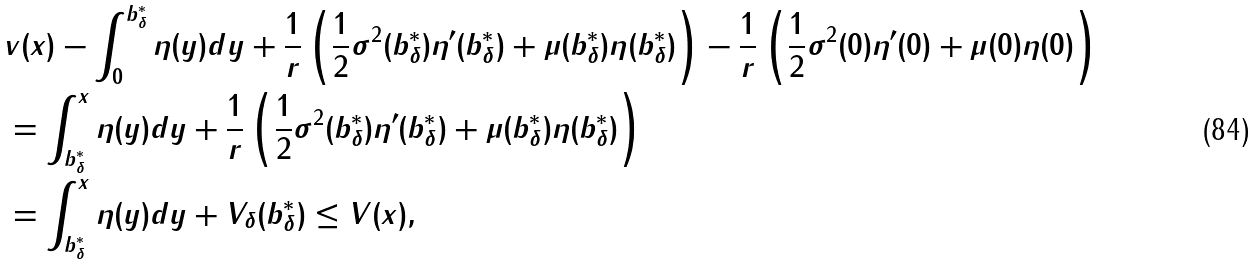Convert formula to latex. <formula><loc_0><loc_0><loc_500><loc_500>& v ( x ) - \int _ { 0 } ^ { b ^ { * } _ { \delta } } \eta ( y ) d y + \frac { 1 } { r } \left ( \frac { 1 } { 2 } \sigma ^ { 2 } ( b ^ { * } _ { \delta } ) \eta ^ { \prime } ( b ^ { * } _ { \delta } ) + \mu ( b ^ { * } _ { \delta } ) \eta ( b ^ { * } _ { \delta } ) \right ) - \frac { 1 } { r } \left ( \frac { 1 } { 2 } \sigma ^ { 2 } ( 0 ) \eta ^ { \prime } ( 0 ) + \mu ( 0 ) \eta ( 0 ) \right ) \\ & = \int _ { b ^ { * } _ { \delta } } ^ { x } \eta ( y ) d y + \frac { 1 } { r } \left ( \frac { 1 } { 2 } \sigma ^ { 2 } ( b ^ { * } _ { \delta } ) \eta ^ { \prime } ( b ^ { * } _ { \delta } ) + \mu ( b ^ { * } _ { \delta } ) \eta ( b ^ { * } _ { \delta } ) \right ) \\ & = \int _ { b ^ { * } _ { \delta } } ^ { x } \eta ( y ) d y + V _ { \delta } ( b ^ { * } _ { \delta } ) \leq V ( x ) ,</formula> 